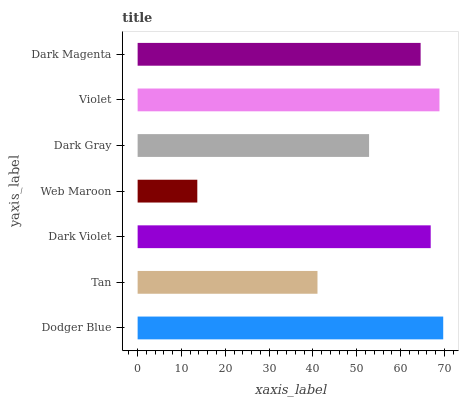Is Web Maroon the minimum?
Answer yes or no. Yes. Is Dodger Blue the maximum?
Answer yes or no. Yes. Is Tan the minimum?
Answer yes or no. No. Is Tan the maximum?
Answer yes or no. No. Is Dodger Blue greater than Tan?
Answer yes or no. Yes. Is Tan less than Dodger Blue?
Answer yes or no. Yes. Is Tan greater than Dodger Blue?
Answer yes or no. No. Is Dodger Blue less than Tan?
Answer yes or no. No. Is Dark Magenta the high median?
Answer yes or no. Yes. Is Dark Magenta the low median?
Answer yes or no. Yes. Is Dodger Blue the high median?
Answer yes or no. No. Is Dodger Blue the low median?
Answer yes or no. No. 